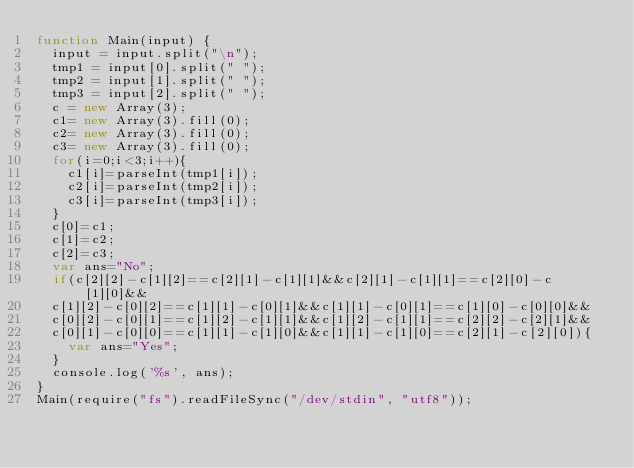<code> <loc_0><loc_0><loc_500><loc_500><_JavaScript_>function Main(input) {
  input = input.split("\n");
  tmp1 = input[0].split(" ");
  tmp2 = input[1].split(" ");
  tmp3 = input[2].split(" ");
  c = new Array(3);
  c1= new Array(3).fill(0);
  c2= new Array(3).fill(0);
  c3= new Array(3).fill(0); 
  for(i=0;i<3;i++){
    c1[i]=parseInt(tmp1[i]);
    c2[i]=parseInt(tmp2[i]);
    c3[i]=parseInt(tmp3[i]);
  }
  c[0]=c1;
  c[1]=c2;
  c[2]=c3;
  var ans="No";
  if(c[2][2]-c[1][2]==c[2][1]-c[1][1]&&c[2][1]-c[1][1]==c[2][0]-c[1][0]&&
  c[1][2]-c[0][2]==c[1][1]-c[0][1]&&c[1][1]-c[0][1]==c[1][0]-c[0][0]&&
  c[0][2]-c[0][1]==c[1][2]-c[1][1]&&c[1][2]-c[1][1]==c[2][2]-c[2][1]&&
  c[0][1]-c[0][0]==c[1][1]-c[1][0]&&c[1][1]-c[1][0]==c[2][1]-c[2][0]){
    var ans="Yes";
  }
  console.log('%s', ans);
}
Main(require("fs").readFileSync("/dev/stdin", "utf8"));</code> 